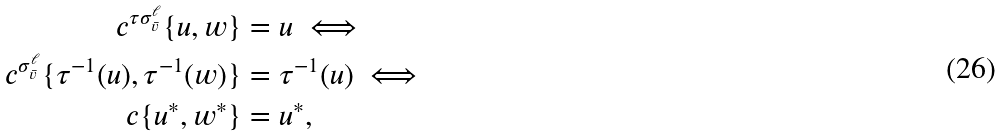Convert formula to latex. <formula><loc_0><loc_0><loc_500><loc_500>c ^ { \tau \sigma ^ { \ell } _ { \bar { v } } } \{ u , w \} & = u \iff \\ c ^ { \sigma ^ { \ell } _ { \bar { v } } } \{ \tau ^ { - 1 } ( u ) , \tau ^ { - 1 } ( w ) \} & = \tau ^ { - 1 } ( u ) \iff \\ c \{ u ^ { * } , w ^ { * } \} & = u ^ { * } ,</formula> 